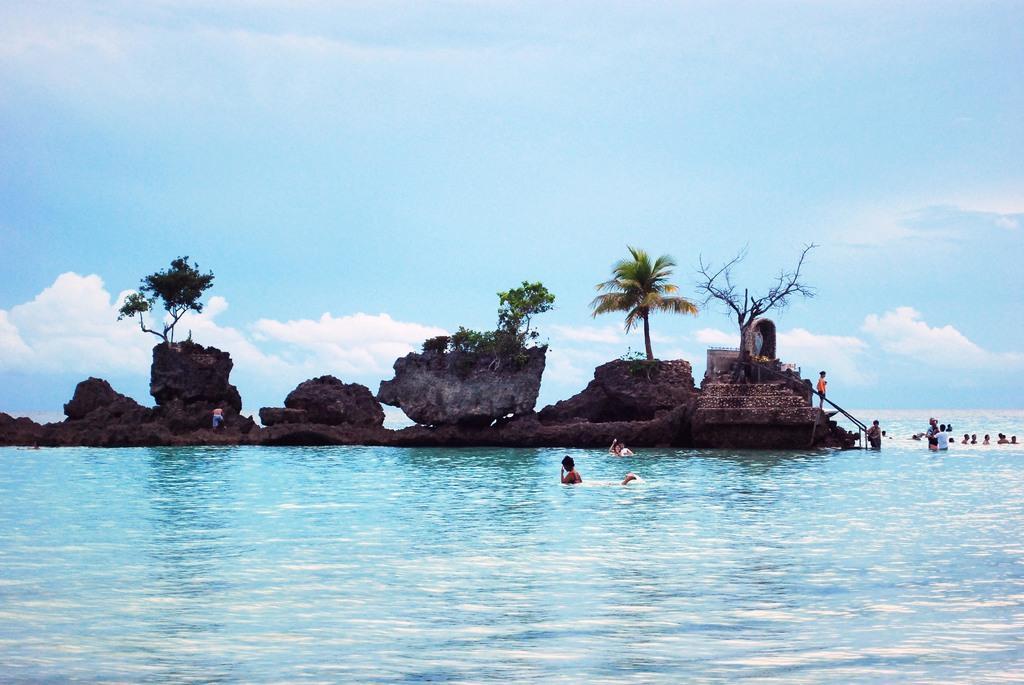Could you give a brief overview of what you see in this image? In this image we can see people standing and swimming in the water, an island with trees and plants and sky in the background. 